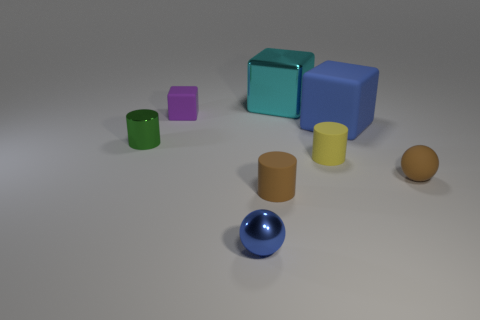There is a tiny cylinder that is right of the metal block; what color is it?
Provide a succinct answer. Yellow. Are there more metallic cylinders that are behind the small green cylinder than small blue metal spheres?
Keep it short and to the point. No. What is the color of the tiny rubber ball?
Give a very brief answer. Brown. There is a small brown rubber thing to the left of the blue object to the right of the tiny cylinder that is on the right side of the cyan metallic object; what is its shape?
Provide a short and direct response. Cylinder. What material is the cylinder that is left of the cyan shiny cube and on the right side of the tiny purple matte block?
Offer a terse response. Rubber. The tiny metal object behind the metal object in front of the green cylinder is what shape?
Your answer should be very brief. Cylinder. Is there any other thing that has the same color as the big metallic block?
Offer a terse response. No. Does the cyan thing have the same size as the matte cylinder that is to the right of the big cyan cube?
Provide a short and direct response. No. What number of small objects are cylinders or metal things?
Keep it short and to the point. 4. Are there more big brown metallic things than blue matte objects?
Give a very brief answer. No. 